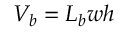Convert formula to latex. <formula><loc_0><loc_0><loc_500><loc_500>V _ { b } = L _ { b } w h</formula> 